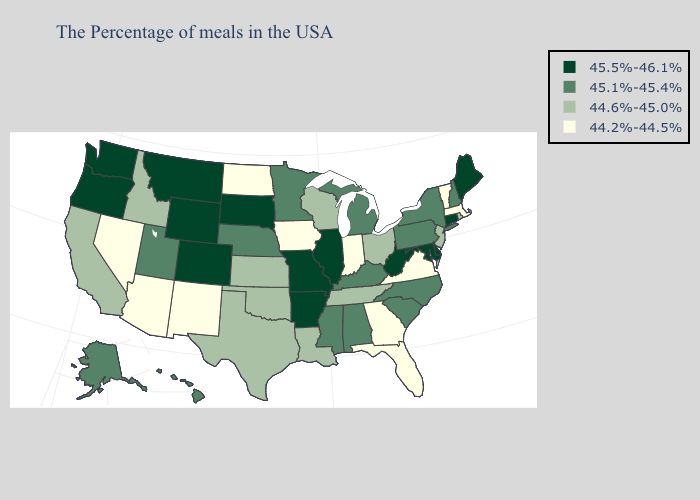Name the states that have a value in the range 44.6%-45.0%?
Write a very short answer. Rhode Island, New Jersey, Ohio, Tennessee, Wisconsin, Louisiana, Kansas, Oklahoma, Texas, Idaho, California. Name the states that have a value in the range 45.5%-46.1%?
Quick response, please. Maine, Connecticut, Delaware, Maryland, West Virginia, Illinois, Missouri, Arkansas, South Dakota, Wyoming, Colorado, Montana, Washington, Oregon. Does Massachusetts have the highest value in the USA?
Keep it brief. No. Among the states that border Georgia , does Alabama have the highest value?
Give a very brief answer. Yes. Name the states that have a value in the range 44.6%-45.0%?
Write a very short answer. Rhode Island, New Jersey, Ohio, Tennessee, Wisconsin, Louisiana, Kansas, Oklahoma, Texas, Idaho, California. What is the lowest value in the USA?
Quick response, please. 44.2%-44.5%. Among the states that border New Jersey , which have the highest value?
Keep it brief. Delaware. What is the value of Iowa?
Answer briefly. 44.2%-44.5%. How many symbols are there in the legend?
Concise answer only. 4. What is the lowest value in states that border Wisconsin?
Quick response, please. 44.2%-44.5%. Among the states that border Tennessee , does Missouri have the lowest value?
Keep it brief. No. What is the highest value in the South ?
Keep it brief. 45.5%-46.1%. Among the states that border Tennessee , which have the lowest value?
Give a very brief answer. Virginia, Georgia. Name the states that have a value in the range 45.5%-46.1%?
Keep it brief. Maine, Connecticut, Delaware, Maryland, West Virginia, Illinois, Missouri, Arkansas, South Dakota, Wyoming, Colorado, Montana, Washington, Oregon. Name the states that have a value in the range 45.5%-46.1%?
Be succinct. Maine, Connecticut, Delaware, Maryland, West Virginia, Illinois, Missouri, Arkansas, South Dakota, Wyoming, Colorado, Montana, Washington, Oregon. 